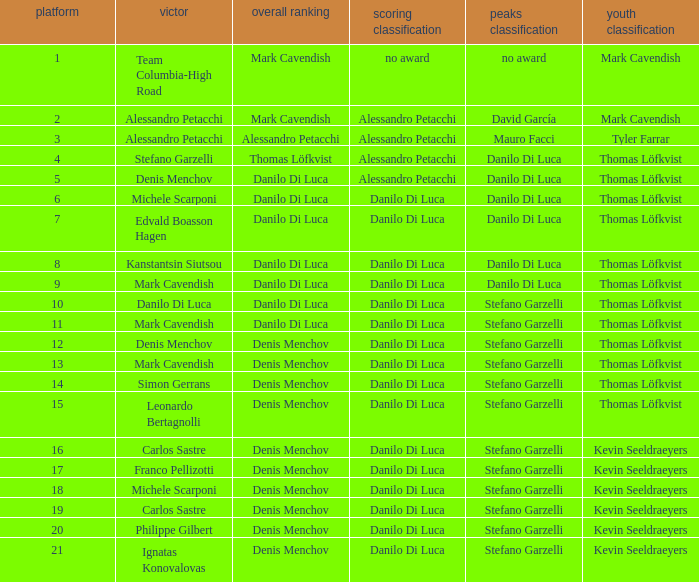Write the full table. {'header': ['platform', 'victor', 'overall ranking', 'scoring classification', 'peaks classification', 'youth classification'], 'rows': [['1', 'Team Columbia-High Road', 'Mark Cavendish', 'no award', 'no award', 'Mark Cavendish'], ['2', 'Alessandro Petacchi', 'Mark Cavendish', 'Alessandro Petacchi', 'David García', 'Mark Cavendish'], ['3', 'Alessandro Petacchi', 'Alessandro Petacchi', 'Alessandro Petacchi', 'Mauro Facci', 'Tyler Farrar'], ['4', 'Stefano Garzelli', 'Thomas Löfkvist', 'Alessandro Petacchi', 'Danilo Di Luca', 'Thomas Löfkvist'], ['5', 'Denis Menchov', 'Danilo Di Luca', 'Alessandro Petacchi', 'Danilo Di Luca', 'Thomas Löfkvist'], ['6', 'Michele Scarponi', 'Danilo Di Luca', 'Danilo Di Luca', 'Danilo Di Luca', 'Thomas Löfkvist'], ['7', 'Edvald Boasson Hagen', 'Danilo Di Luca', 'Danilo Di Luca', 'Danilo Di Luca', 'Thomas Löfkvist'], ['8', 'Kanstantsin Siutsou', 'Danilo Di Luca', 'Danilo Di Luca', 'Danilo Di Luca', 'Thomas Löfkvist'], ['9', 'Mark Cavendish', 'Danilo Di Luca', 'Danilo Di Luca', 'Danilo Di Luca', 'Thomas Löfkvist'], ['10', 'Danilo Di Luca', 'Danilo Di Luca', 'Danilo Di Luca', 'Stefano Garzelli', 'Thomas Löfkvist'], ['11', 'Mark Cavendish', 'Danilo Di Luca', 'Danilo Di Luca', 'Stefano Garzelli', 'Thomas Löfkvist'], ['12', 'Denis Menchov', 'Denis Menchov', 'Danilo Di Luca', 'Stefano Garzelli', 'Thomas Löfkvist'], ['13', 'Mark Cavendish', 'Denis Menchov', 'Danilo Di Luca', 'Stefano Garzelli', 'Thomas Löfkvist'], ['14', 'Simon Gerrans', 'Denis Menchov', 'Danilo Di Luca', 'Stefano Garzelli', 'Thomas Löfkvist'], ['15', 'Leonardo Bertagnolli', 'Denis Menchov', 'Danilo Di Luca', 'Stefano Garzelli', 'Thomas Löfkvist'], ['16', 'Carlos Sastre', 'Denis Menchov', 'Danilo Di Luca', 'Stefano Garzelli', 'Kevin Seeldraeyers'], ['17', 'Franco Pellizotti', 'Denis Menchov', 'Danilo Di Luca', 'Stefano Garzelli', 'Kevin Seeldraeyers'], ['18', 'Michele Scarponi', 'Denis Menchov', 'Danilo Di Luca', 'Stefano Garzelli', 'Kevin Seeldraeyers'], ['19', 'Carlos Sastre', 'Denis Menchov', 'Danilo Di Luca', 'Stefano Garzelli', 'Kevin Seeldraeyers'], ['20', 'Philippe Gilbert', 'Denis Menchov', 'Danilo Di Luca', 'Stefano Garzelli', 'Kevin Seeldraeyers'], ['21', 'Ignatas Konovalovas', 'Denis Menchov', 'Danilo Di Luca', 'Stefano Garzelli', 'Kevin Seeldraeyers']]} When thomas löfkvist is the  young rider classification and alessandro petacchi is the points classification who are the general classifications?  Thomas Löfkvist, Danilo Di Luca. 